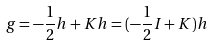Convert formula to latex. <formula><loc_0><loc_0><loc_500><loc_500>g = - \frac { 1 } { 2 } h + { K } h = ( - \frac { 1 } { 2 } { I } + { K } ) h</formula> 